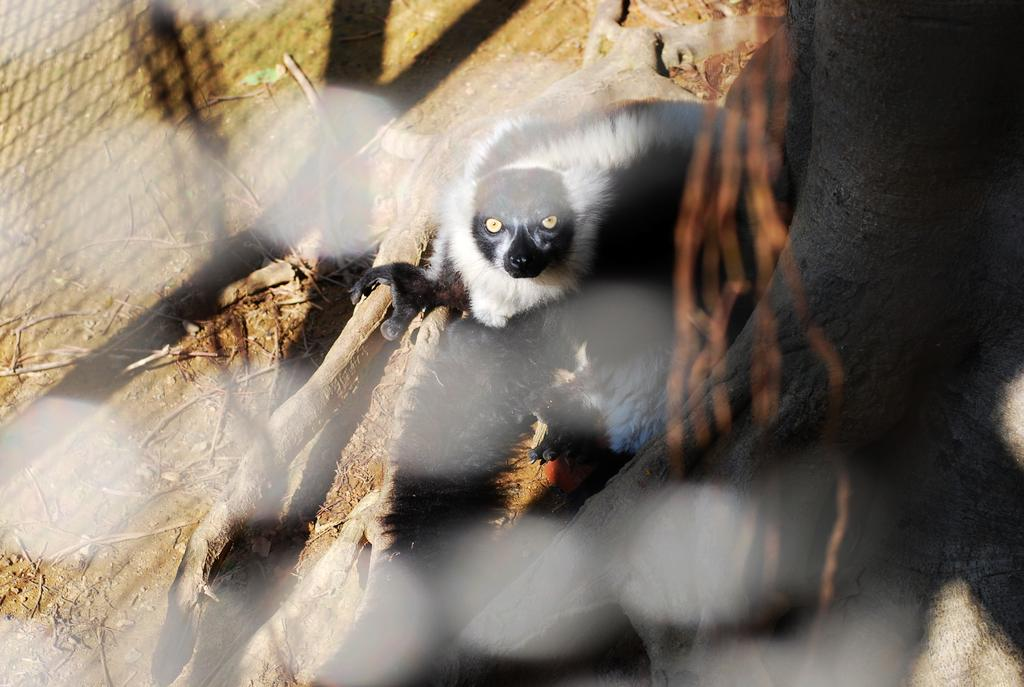What type of animal can be seen in the image? There is an animal in the image, and it has white and black coloring. What is the animal sitting on or near in the image? There is a tree branch in the image. What can be seen below the animal in the image? The ground is visible in the image. What is the rate of egg production in the image? There is no mention of eggs or egg production in the image, so this question cannot be answered. 